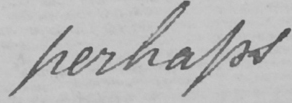Please provide the text content of this handwritten line. perhaps 